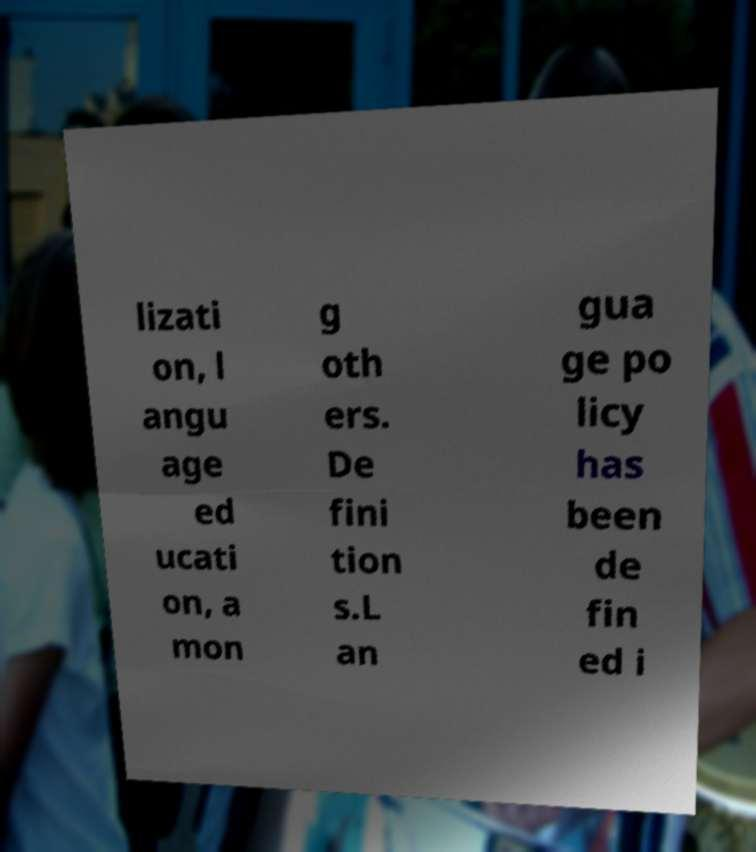For documentation purposes, I need the text within this image transcribed. Could you provide that? lizati on, l angu age ed ucati on, a mon g oth ers. De fini tion s.L an gua ge po licy has been de fin ed i 